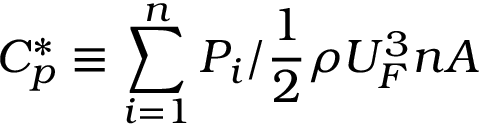Convert formula to latex. <formula><loc_0><loc_0><loc_500><loc_500>C _ { p } ^ { * } \equiv \sum _ { i = 1 } ^ { n } P _ { i } / \frac { 1 } { 2 } \rho U _ { F } ^ { 3 } n A</formula> 